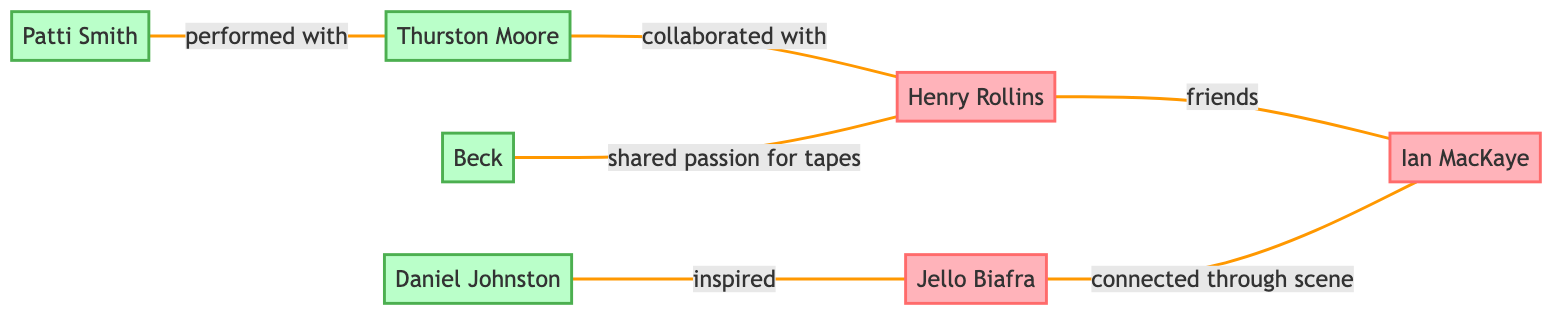What is the relationship between Henry Rollins and Ian MacKaye? Henry Rollins and Ian MacKaye are connected by the relationship labeled "friends", as indicated by the edge connecting their nodes in the diagram.
Answer: friends Who inspired Daniel Johnston? The diagram shows an edge labeled "inspired" connecting Daniel Johnston to Jello Biafra, indicating that Jello Biafra is the one who inspired him.
Answer: Jello Biafra How many musicians are represented in the diagram? The diagram lists four musicians: Thurston Moore, Daniel Johnston, Patti Smith, and Beck. By counting these nodes, we find there are four musicians in total.
Answer: 4 What type of connection exists between Thurston Moore and Henry Rollins? In the diagram, there is an edge labeled "collaborated with" that connects Thurston Moore to Henry Rollins, indicating the nature of their relationship.
Answer: collaborated with Which cassette tape collector has a connection through the scene? The diagram shows an edge labeled "connected through scene" between Jello Biafra and Ian MacKaye, implying that both are cassette tape collectors with this specific connection.
Answer: Jello Biafra How many edges are present in the diagram? By examining the edges listed in the diagram, we see there are a total of six edges connecting the various nodes, representing different relationships.
Answer: 6 Name a musician who performed with Patti Smith. The diagram indicates that Patti Smith has an edge labeled "performed with" connecting her to Thurston Moore, revealing that he is the musician associated with her performances.
Answer: Thurston Moore Which two collectors share a passion for tapes according to the diagram? The edge shows that Henry Rollins and Beck have a connection labeled "shared passion for tapes", indicating they both share this particular interest.
Answer: Henry Rollins and Beck Who has the most connections in the diagram? By reviewing the edges connected to each node, we see that Henry Rollins has three edges connecting him to Ian MacKaye, Thurston Moore, and Beck, making him the most connected individual.
Answer: Henry Rollins 